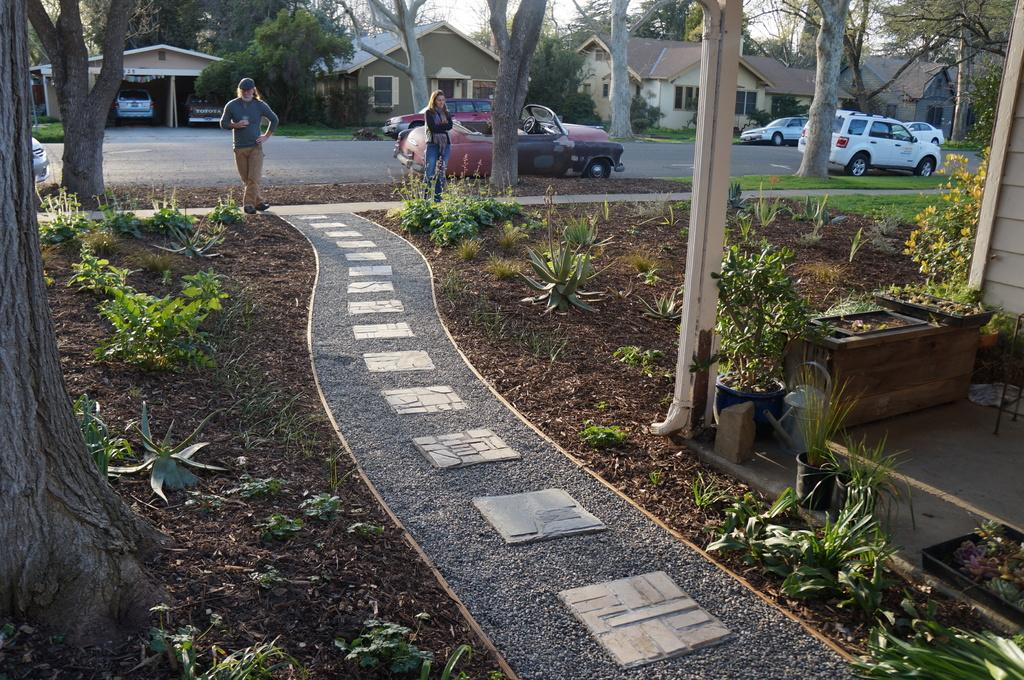How many people are standing in the image? There are two people standing in the image. What is in front of the people? There are plants and trees in front of the people. What can be seen in the image besides the people? There is a pillar, cars, trees, and houses behind the people. What type of thumb is being used to sense the ground in the image? There is no thumb or sense of the ground being used in the image; it is a scene of people standing on a pavement with plants, trees, and other objects in the background. 